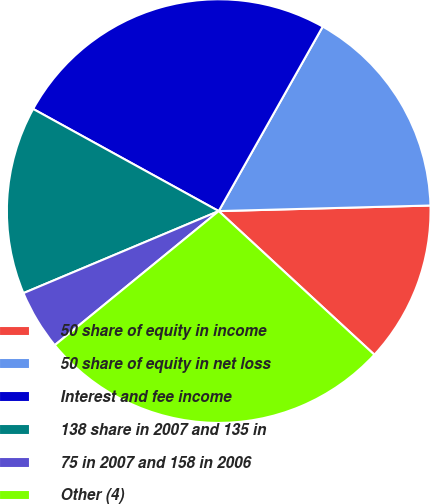<chart> <loc_0><loc_0><loc_500><loc_500><pie_chart><fcel>50 share of equity in income<fcel>50 share of equity in net loss<fcel>Interest and fee income<fcel>138 share in 2007 and 135 in<fcel>75 in 2007 and 158 in 2006<fcel>Other (4)<nl><fcel>12.28%<fcel>16.41%<fcel>25.16%<fcel>14.34%<fcel>4.58%<fcel>27.23%<nl></chart> 